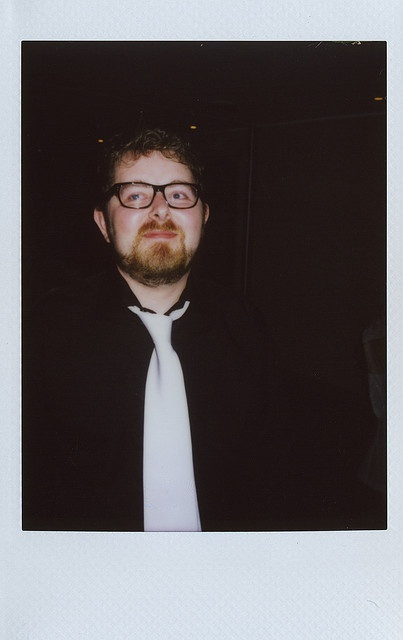Describe the objects in this image and their specific colors. I can see people in lightgray, black, darkgray, and gray tones and tie in lightgray and darkgray tones in this image. 